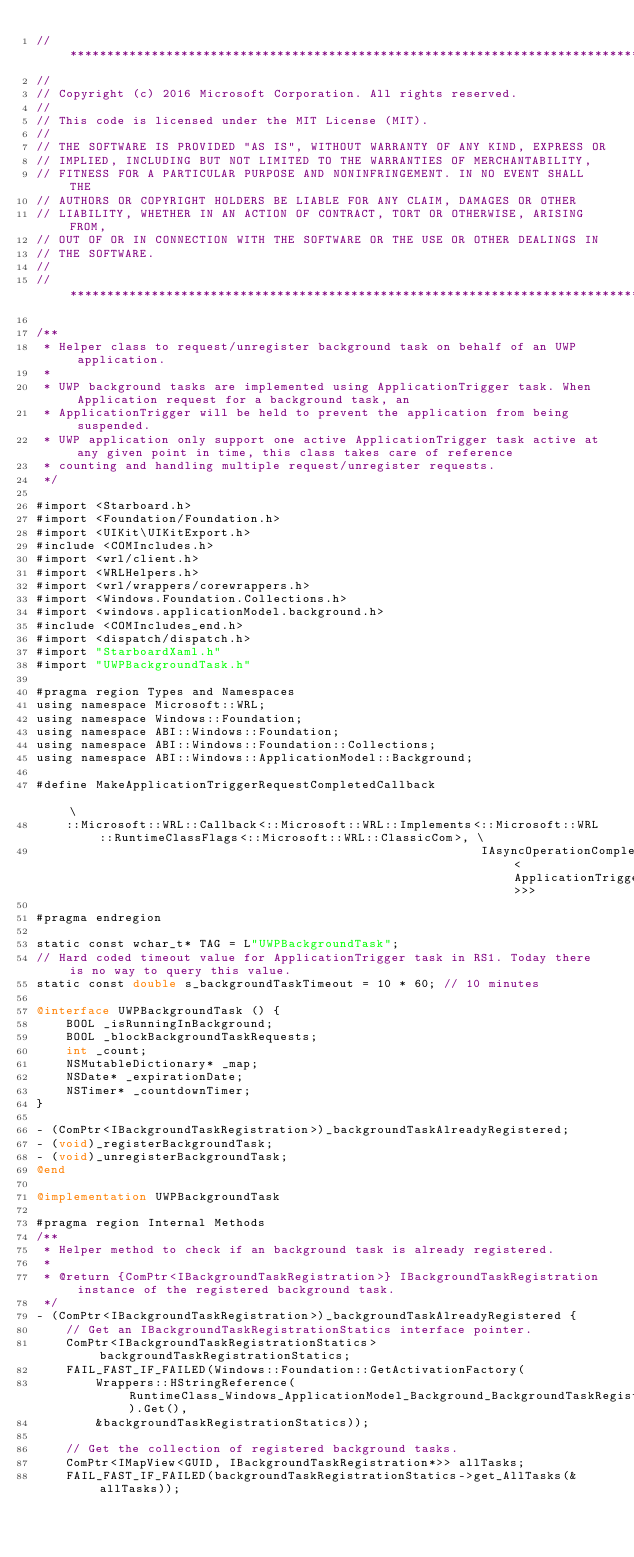Convert code to text. <code><loc_0><loc_0><loc_500><loc_500><_ObjectiveC_>//******************************************************************************
//
// Copyright (c) 2016 Microsoft Corporation. All rights reserved.
//
// This code is licensed under the MIT License (MIT).
//
// THE SOFTWARE IS PROVIDED "AS IS", WITHOUT WARRANTY OF ANY KIND, EXPRESS OR
// IMPLIED, INCLUDING BUT NOT LIMITED TO THE WARRANTIES OF MERCHANTABILITY,
// FITNESS FOR A PARTICULAR PURPOSE AND NONINFRINGEMENT. IN NO EVENT SHALL THE
// AUTHORS OR COPYRIGHT HOLDERS BE LIABLE FOR ANY CLAIM, DAMAGES OR OTHER
// LIABILITY, WHETHER IN AN ACTION OF CONTRACT, TORT OR OTHERWISE, ARISING FROM,
// OUT OF OR IN CONNECTION WITH THE SOFTWARE OR THE USE OR OTHER DEALINGS IN
// THE SOFTWARE.
//
//******************************************************************************

/**
 * Helper class to request/unregister background task on behalf of an UWP application.
 *
 * UWP background tasks are implemented using ApplicationTrigger task. When Application request for a background task, an
 * ApplicationTrigger will be held to prevent the application from being suspended.
 * UWP application only support one active ApplicationTrigger task active at any given point in time, this class takes care of reference
 * counting and handling multiple request/unregister requests.
 */

#import <Starboard.h>
#import <Foundation/Foundation.h>
#import <UIKit\UIKitExport.h>
#include <COMIncludes.h>
#import <wrl/client.h>
#import <WRLHelpers.h>
#import <wrl/wrappers/corewrappers.h>
#import <Windows.Foundation.Collections.h>
#import <windows.applicationModel.background.h>
#include <COMIncludes_end.h>
#import <dispatch/dispatch.h>
#import "StarboardXaml.h"
#import "UWPBackgroundTask.h"

#pragma region Types and Namespaces
using namespace Microsoft::WRL;
using namespace Windows::Foundation;
using namespace ABI::Windows::Foundation;
using namespace ABI::Windows::Foundation::Collections;
using namespace ABI::Windows::ApplicationModel::Background;

#define MakeApplicationTriggerRequestCompletedCallback                                                                         \
    ::Microsoft::WRL::Callback<::Microsoft::WRL::Implements<::Microsoft::WRL::RuntimeClassFlags<::Microsoft::WRL::ClassicCom>, \
                                                            IAsyncOperationCompletedHandler<ApplicationTriggerResult>>>

#pragma endregion

static const wchar_t* TAG = L"UWPBackgroundTask";
// Hard coded timeout value for ApplicationTrigger task in RS1. Today there is no way to query this value.
static const double s_backgroundTaskTimeout = 10 * 60; // 10 minutes

@interface UWPBackgroundTask () {
    BOOL _isRunningInBackground;
    BOOL _blockBackgroundTaskRequests;
    int _count;
    NSMutableDictionary* _map;
    NSDate* _expirationDate;
    NSTimer* _countdownTimer;
}

- (ComPtr<IBackgroundTaskRegistration>)_backgroundTaskAlreadyRegistered;
- (void)_registerBackgroundTask;
- (void)_unregisterBackgroundTask;
@end

@implementation UWPBackgroundTask

#pragma region Internal Methods
/**
 * Helper method to check if an background task is already registered.
 *
 * @return {ComPtr<IBackgroundTaskRegistration>} IBackgroundTaskRegistration instance of the registered background task.
 */
- (ComPtr<IBackgroundTaskRegistration>)_backgroundTaskAlreadyRegistered {
    // Get an IBackgroundTaskRegistrationStatics interface pointer.
    ComPtr<IBackgroundTaskRegistrationStatics> backgroundTaskRegistrationStatics;
    FAIL_FAST_IF_FAILED(Windows::Foundation::GetActivationFactory(
        Wrappers::HStringReference(RuntimeClass_Windows_ApplicationModel_Background_BackgroundTaskRegistration).Get(),
        &backgroundTaskRegistrationStatics));

    // Get the collection of registered background tasks.
    ComPtr<IMapView<GUID, IBackgroundTaskRegistration*>> allTasks;
    FAIL_FAST_IF_FAILED(backgroundTaskRegistrationStatics->get_AllTasks(&allTasks));
</code> 